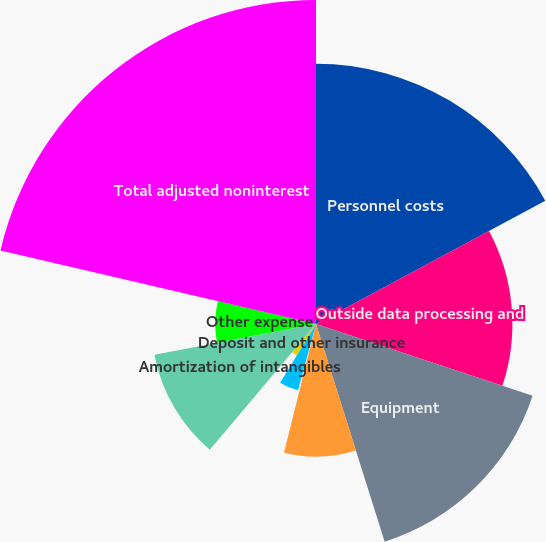<chart> <loc_0><loc_0><loc_500><loc_500><pie_chart><fcel>Personnel costs<fcel>Outside data processing and<fcel>Equipment<fcel>Net occupancy<fcel>Professional services<fcel>Marketing<fcel>Deposit and other insurance<fcel>Amortization of intangibles<fcel>Other expense<fcel>Total adjusted noninterest<nl><fcel>17.15%<fcel>12.94%<fcel>15.04%<fcel>8.74%<fcel>0.33%<fcel>4.53%<fcel>2.43%<fcel>10.84%<fcel>6.64%<fcel>21.35%<nl></chart> 